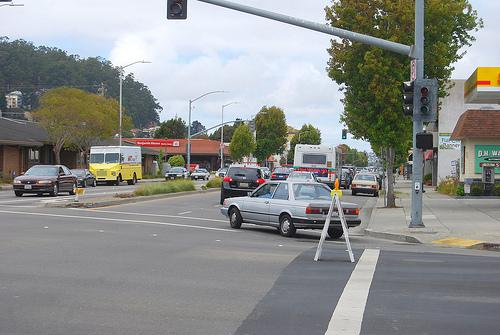Question: what building is on the corner?
Choices:
A. A library.
B. A firehouse.
C. A gas station.
D. Town Hall.
Answer with the letter. Answer: C Question: how is the weather?
Choices:
A. It's sunny.
B. It's snowing.
C. It's cloudy.
D. It's raining.
Answer with the letter. Answer: C Question: what color are the stripes on the road?
Choices:
A. Red.
B. Yellow.
C. Gold.
D. White.
Answer with the letter. Answer: D 